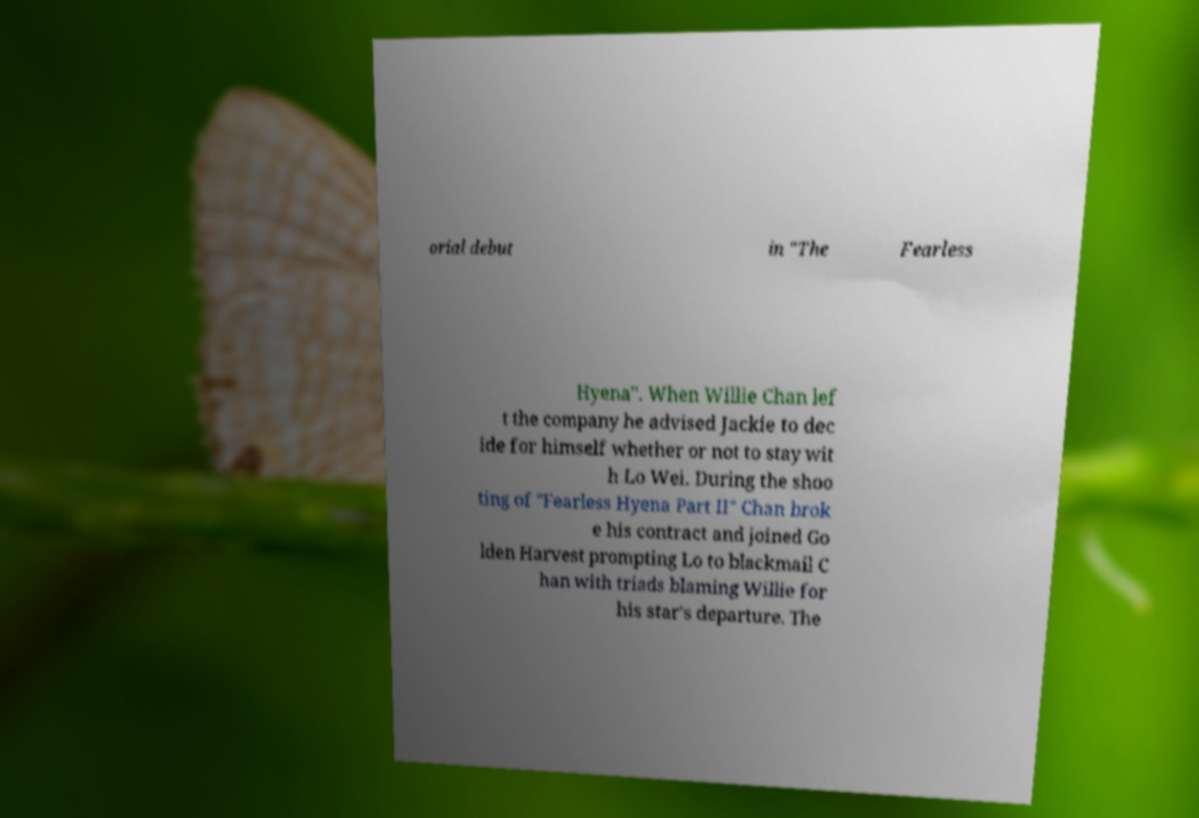Please identify and transcribe the text found in this image. orial debut in "The Fearless Hyena". When Willie Chan lef t the company he advised Jackie to dec ide for himself whether or not to stay wit h Lo Wei. During the shoo ting of "Fearless Hyena Part II" Chan brok e his contract and joined Go lden Harvest prompting Lo to blackmail C han with triads blaming Willie for his star's departure. The 